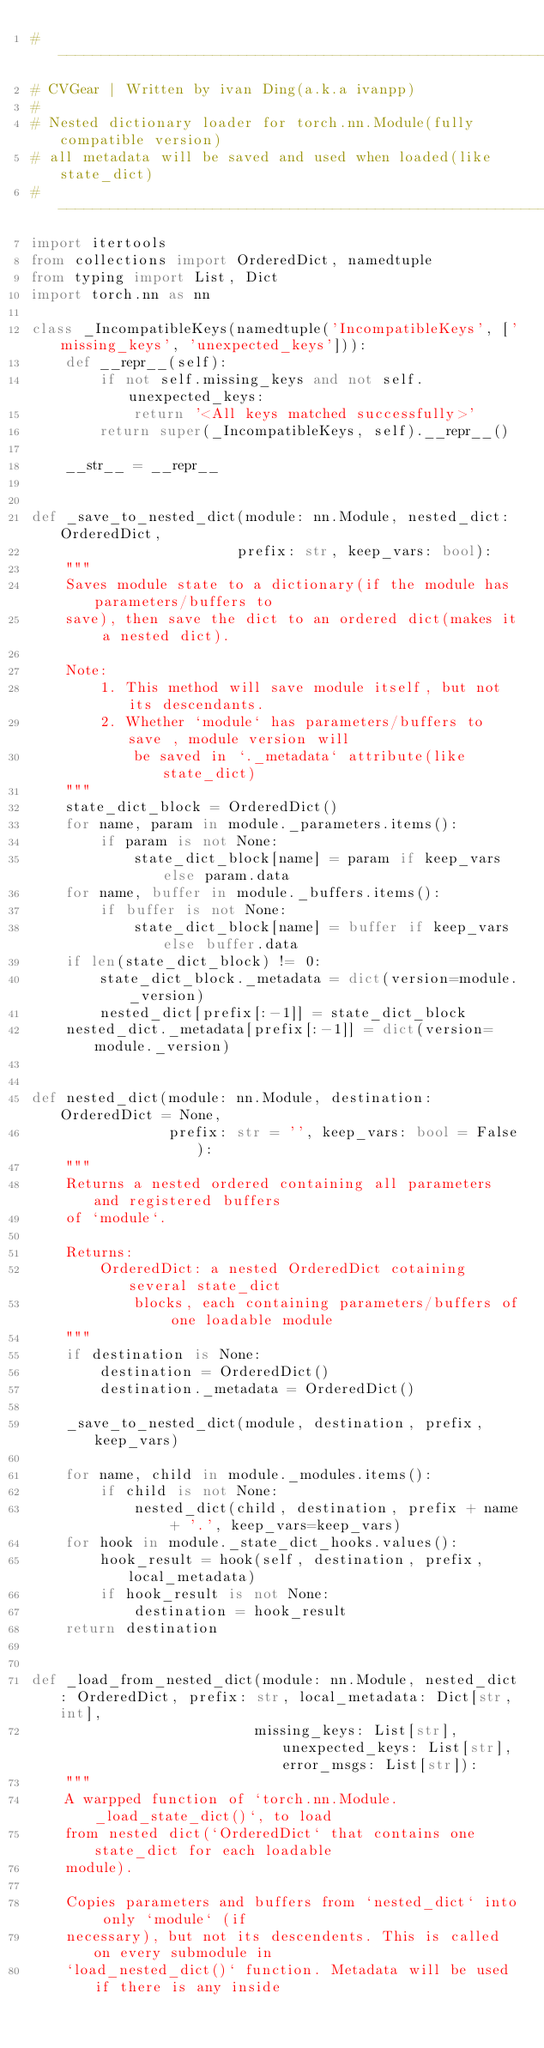<code> <loc_0><loc_0><loc_500><loc_500><_Python_># ----------------------------------------------------------------------
# CVGear | Written by ivan Ding(a.k.a ivanpp)
#
# Nested dictionary loader for torch.nn.Module(fully compatible version)
# all metadata will be saved and used when loaded(like state_dict)
# ----------------------------------------------------------------------
import itertools
from collections import OrderedDict, namedtuple
from typing import List, Dict
import torch.nn as nn

class _IncompatibleKeys(namedtuple('IncompatibleKeys', ['missing_keys', 'unexpected_keys'])):
    def __repr__(self):
        if not self.missing_keys and not self.unexpected_keys:
            return '<All keys matched successfully>'
        return super(_IncompatibleKeys, self).__repr__()

    __str__ = __repr__


def _save_to_nested_dict(module: nn.Module, nested_dict: OrderedDict,
                        prefix: str, keep_vars: bool):
    """
    Saves module state to a dictionary(if the module has parameters/buffers to 
    save), then save the dict to an ordered dict(makes it a nested dict).
    
    Note:
        1. This method will save module itself, but not its descendants.
        2. Whether `module` has parameters/buffers to save , module version will
            be saved in `._metadata` attribute(like state_dict)
    """
    state_dict_block = OrderedDict()
    for name, param in module._parameters.items():
        if param is not None:
            state_dict_block[name] = param if keep_vars else param.data
    for name, buffer in module._buffers.items():
        if buffer is not None:
            state_dict_block[name] = buffer if keep_vars else buffer.data
    if len(state_dict_block) != 0:
        state_dict_block._metadata = dict(version=module._version)
        nested_dict[prefix[:-1]] = state_dict_block
    nested_dict._metadata[prefix[:-1]] = dict(version=module._version)


def nested_dict(module: nn.Module, destination: OrderedDict = None, 
                prefix: str = '', keep_vars: bool = False):
    """
    Returns a nested ordered containing all parameters and registered buffers 
    of `module`.

    Returns:
        OrderedDict: a nested OrderedDict cotaining several state_dict
            blocks, each containing parameters/buffers of one loadable module
    """
    if destination is None:
        destination = OrderedDict()
        destination._metadata = OrderedDict()
    
    _save_to_nested_dict(module, destination, prefix, keep_vars)

    for name, child in module._modules.items():
        if child is not None:
            nested_dict(child, destination, prefix + name + '.', keep_vars=keep_vars)
    for hook in module._state_dict_hooks.values():
        hook_result = hook(self, destination, prefix, local_metadata)
        if hook_result is not None:
            destination = hook_result
    return destination


def _load_from_nested_dict(module: nn.Module, nested_dict: OrderedDict, prefix: str, local_metadata: Dict[str, int],
                          missing_keys: List[str], unexpected_keys: List[str], error_msgs: List[str]):
    """
    A warpped function of `torch.nn.Module._load_state_dict()`, to load
    from nested dict(`OrderedDict` that contains one state_dict for each loadable 
    module).
    
    Copies parameters and buffers from `nested_dict` into only `module` (if
    necessary), but not its descendents. This is called on every submodule in
    `load_nested_dict()` function. Metadata will be used if there is any inside</code> 